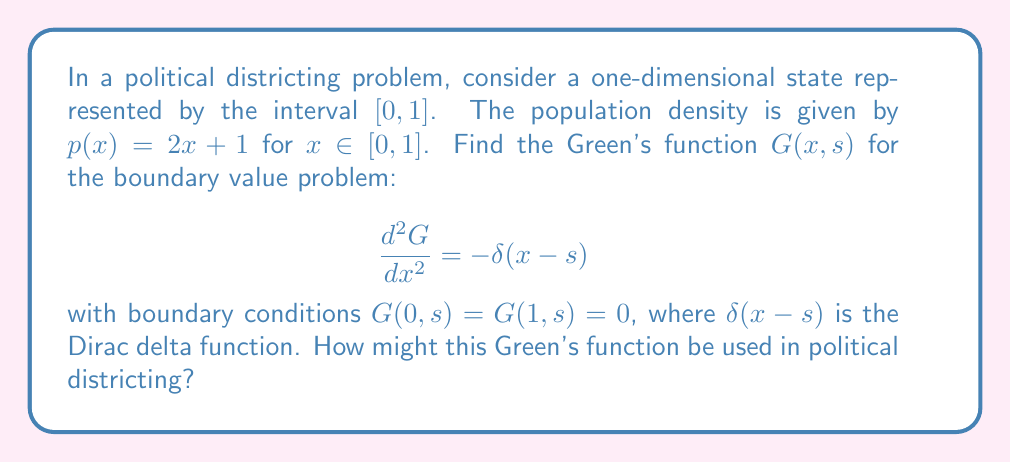Give your solution to this math problem. To solve this problem, we'll follow these steps:

1) The Green's function for this boundary value problem can be constructed as:

   $$G(x, s) = \begin{cases}
   A(s)x, & 0 \leq x \leq s \\
   B(s)(1-x), & s \leq x \leq 1
   \end{cases}$$

   where $A(s)$ and $B(s)$ are functions to be determined.

2) The boundary conditions are already satisfied by this form.

3) The Green's function must be continuous at $x = s$:

   $$A(s)s = B(s)(1-s)$$

4) The derivative of $G$ with respect to $x$ must have a jump discontinuity of -1 at $x = s$:

   $$A(s) - (-B(s)) = -1$$

5) Solving these two equations:

   $$A(s) = 1-s$$
   $$B(s) = s$$

6) Therefore, the Green's function is:

   $$G(x, s) = \begin{cases}
   (1-s)x, & 0 \leq x \leq s \\
   s(1-x), & s \leq x \leq 1
   \end{cases}$$

7) In political districting, this Green's function could be used to model the redistribution of population. The function $G(x, s)$ represents the effect at point $x$ of a unit impulse at point $s$. 

8) For example, if we want to find the new population distribution after redistricting, we could use:

   $$p_{new}(x) = p(x) + \int_0^1 G(x, s)f(s)ds$$

   where $f(s)$ represents the redistricting changes.

9) This approach allows for a continuous model of population shifts, which could be useful for analyzing the effects of different districting plans on population distribution and representation.
Answer: $$G(x, s) = \begin{cases}
(1-s)x, & 0 \leq x \leq s \\
s(1-x), & s \leq x \leq 1
\end{cases}$$ 